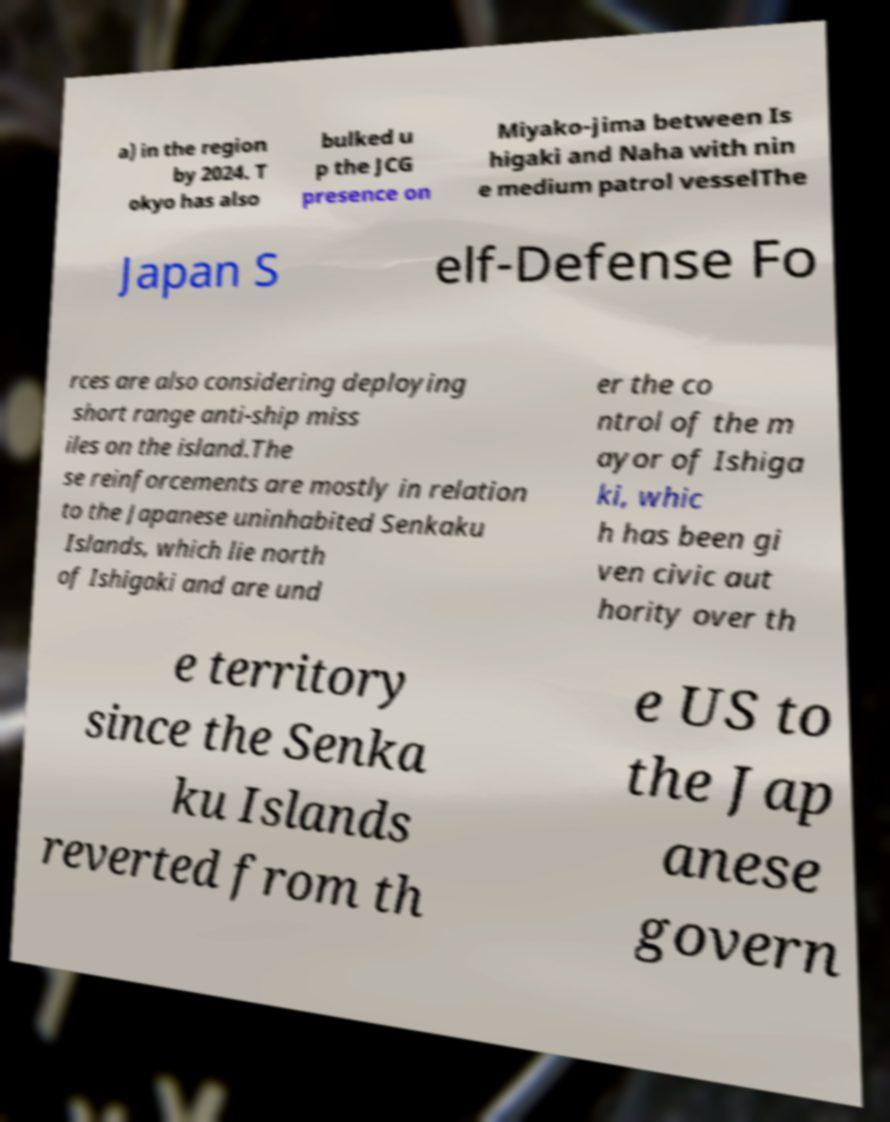Can you accurately transcribe the text from the provided image for me? a) in the region by 2024. T okyo has also bulked u p the JCG presence on Miyako-jima between Is higaki and Naha with nin e medium patrol vesselThe Japan S elf-Defense Fo rces are also considering deploying short range anti-ship miss iles on the island.The se reinforcements are mostly in relation to the Japanese uninhabited Senkaku Islands, which lie north of Ishigaki and are und er the co ntrol of the m ayor of Ishiga ki, whic h has been gi ven civic aut hority over th e territory since the Senka ku Islands reverted from th e US to the Jap anese govern 